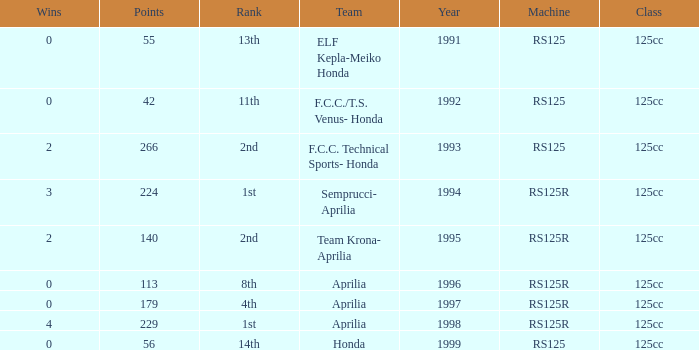Which team had a year over 1995, machine of RS125R, and ranked 1st? Aprilia. 